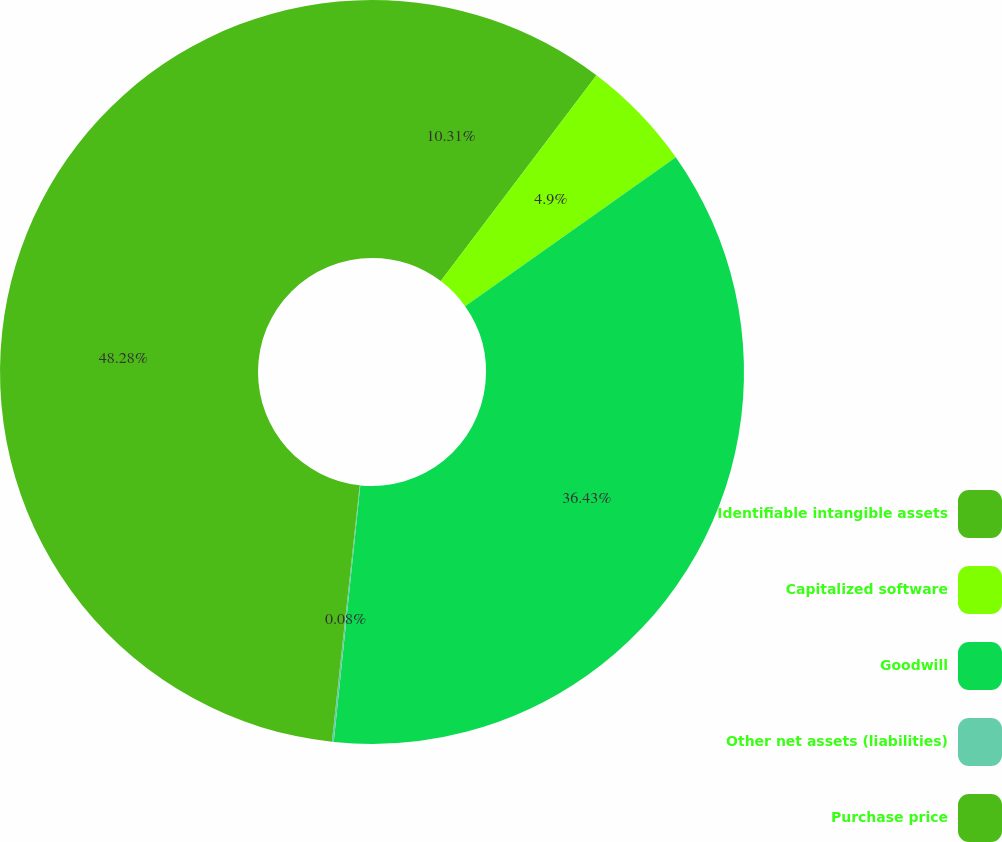Convert chart. <chart><loc_0><loc_0><loc_500><loc_500><pie_chart><fcel>Identifiable intangible assets<fcel>Capitalized software<fcel>Goodwill<fcel>Other net assets (liabilities)<fcel>Purchase price<nl><fcel>10.31%<fcel>4.9%<fcel>36.43%<fcel>0.08%<fcel>48.28%<nl></chart> 